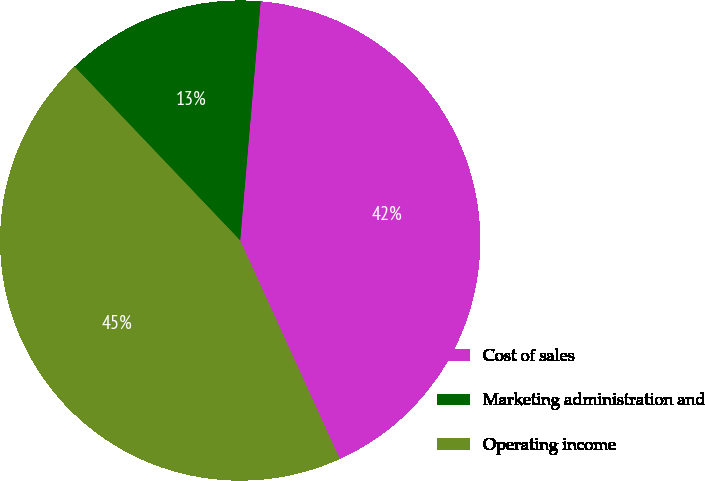Convert chart. <chart><loc_0><loc_0><loc_500><loc_500><pie_chart><fcel>Cost of sales<fcel>Marketing administration and<fcel>Operating income<nl><fcel>41.83%<fcel>13.47%<fcel>44.7%<nl></chart> 